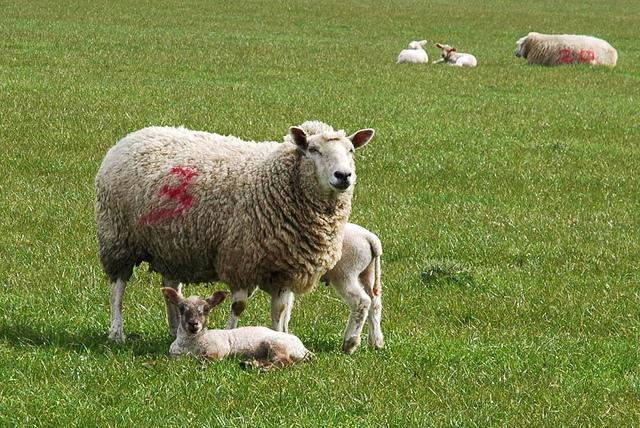What material do these animals provide for clothing? wool 